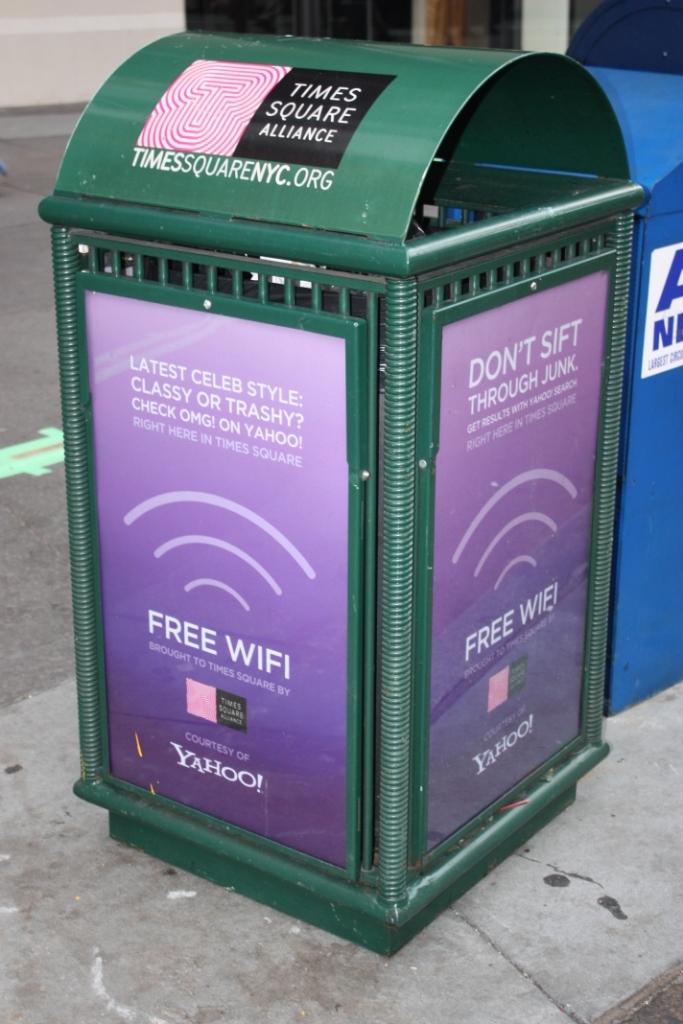What is free according to the trash can?
Your response must be concise. Wifi. 